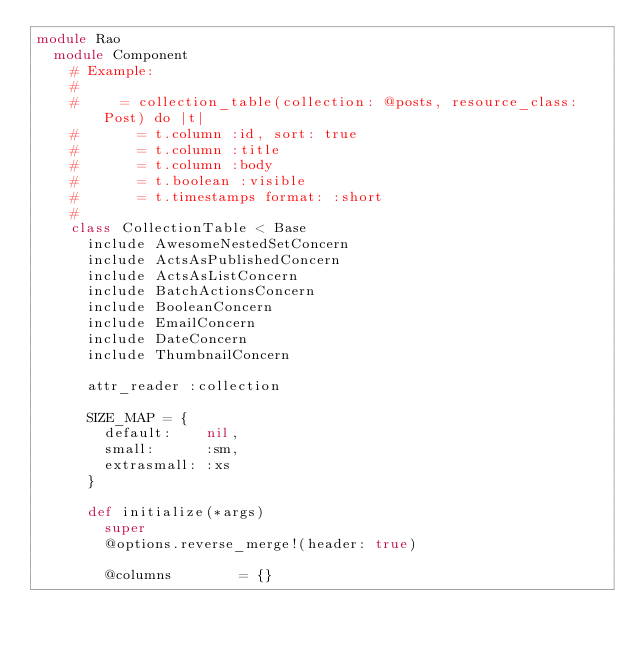<code> <loc_0><loc_0><loc_500><loc_500><_Ruby_>module Rao
  module Component
    # Example:
    #
    #     = collection_table(collection: @posts, resource_class: Post) do |t|
    #       = t.column :id, sort: true
    #       = t.column :title
    #       = t.column :body
    #       = t.boolean :visible
    #       = t.timestamps format: :short
    #
    class CollectionTable < Base
      include AwesomeNestedSetConcern
      include ActsAsPublishedConcern
      include ActsAsListConcern
      include BatchActionsConcern
      include BooleanConcern
      include EmailConcern
      include DateConcern
      include ThumbnailConcern

      attr_reader :collection

      SIZE_MAP = {
        default:    nil,
        small:      :sm,
        extrasmall: :xs
      }

      def initialize(*args)
        super
        @options.reverse_merge!(header: true)

        @columns        = {}</code> 